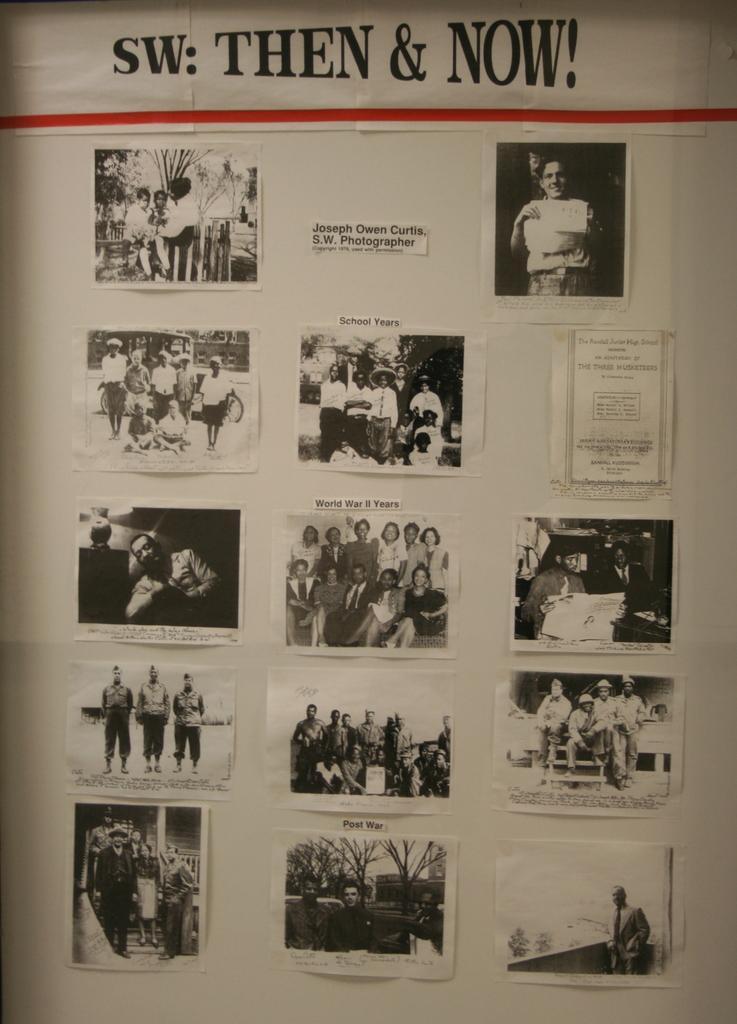Can you describe this image briefly? In this picture there is a white color object seems to be a paper on which we can see the text and pictures containing group of persons, trees and some other objects. 